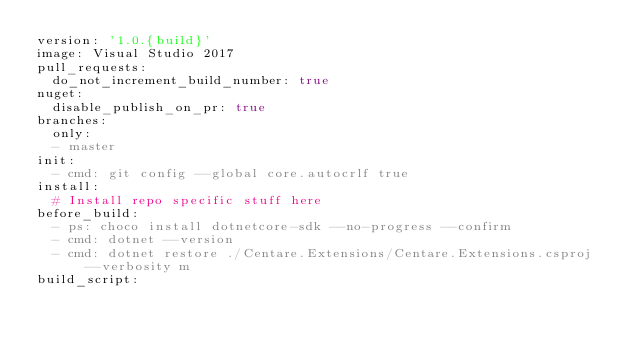<code> <loc_0><loc_0><loc_500><loc_500><_YAML_>version: '1.0.{build}'
image: Visual Studio 2017
pull_requests:  
  do_not_increment_build_number: true
nuget:  
  disable_publish_on_pr: true
branches:
  only:
  - master
init:
  - cmd: git config --global core.autocrlf true
install:
  # Install repo specific stuff here
before_build:
  - ps: choco install dotnetcore-sdk --no-progress --confirm
  - cmd: dotnet --version
  - cmd: dotnet restore ./Centare.Extensions/Centare.Extensions.csproj --verbosity m
build_script:</code> 